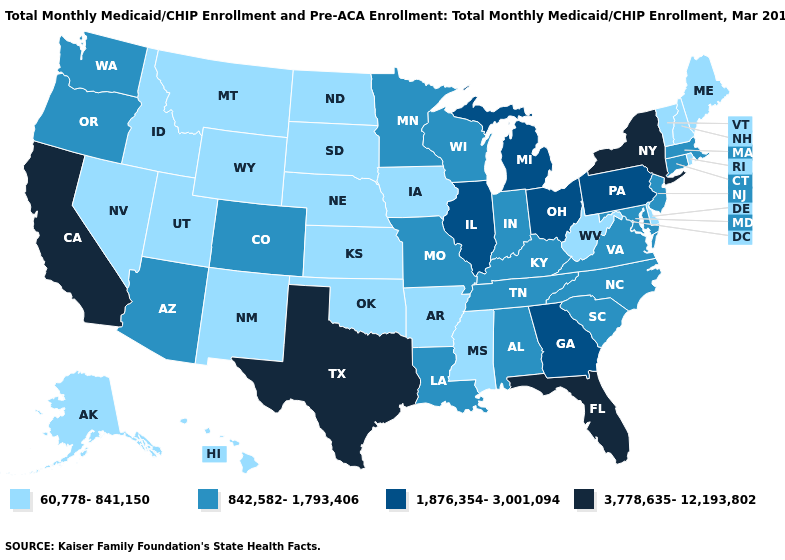Does the map have missing data?
Concise answer only. No. Does Nebraska have the lowest value in the USA?
Give a very brief answer. Yes. Name the states that have a value in the range 1,876,354-3,001,094?
Keep it brief. Georgia, Illinois, Michigan, Ohio, Pennsylvania. Which states have the lowest value in the West?
Quick response, please. Alaska, Hawaii, Idaho, Montana, Nevada, New Mexico, Utah, Wyoming. Name the states that have a value in the range 1,876,354-3,001,094?
Short answer required. Georgia, Illinois, Michigan, Ohio, Pennsylvania. Among the states that border New Hampshire , which have the highest value?
Write a very short answer. Massachusetts. What is the value of Delaware?
Quick response, please. 60,778-841,150. Does Mississippi have a higher value than Massachusetts?
Be succinct. No. Which states have the lowest value in the South?
Quick response, please. Arkansas, Delaware, Mississippi, Oklahoma, West Virginia. Does the first symbol in the legend represent the smallest category?
Quick response, please. Yes. Does Oklahoma have the lowest value in the South?
Give a very brief answer. Yes. Does California have a higher value than Florida?
Write a very short answer. No. Is the legend a continuous bar?
Quick response, please. No. Does Washington have the lowest value in the USA?
Write a very short answer. No. Name the states that have a value in the range 842,582-1,793,406?
Write a very short answer. Alabama, Arizona, Colorado, Connecticut, Indiana, Kentucky, Louisiana, Maryland, Massachusetts, Minnesota, Missouri, New Jersey, North Carolina, Oregon, South Carolina, Tennessee, Virginia, Washington, Wisconsin. 